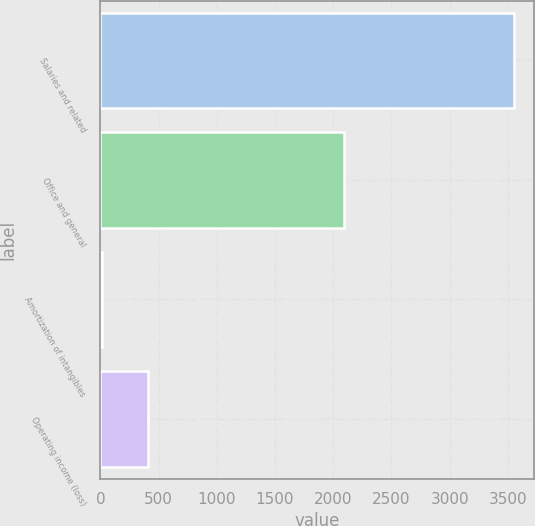Convert chart to OTSL. <chart><loc_0><loc_0><loc_500><loc_500><bar_chart><fcel>Salaries and related<fcel>Office and general<fcel>Amortization of intangibles<fcel>Operating income (loss)<nl><fcel>3549<fcel>2096.6<fcel>13<fcel>405.8<nl></chart> 